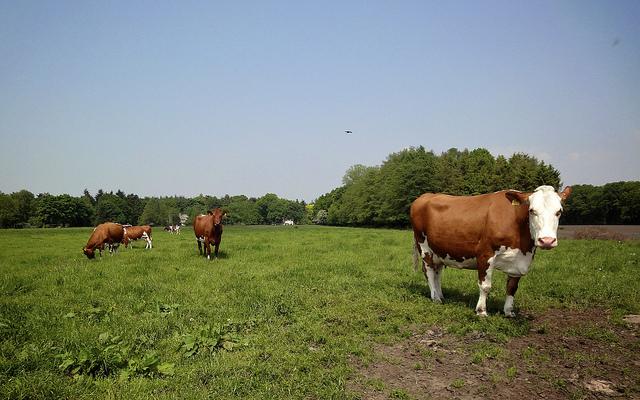Is he fenced in?
Answer briefly. No. Is the sky cloudy or clear?
Be succinct. Clear. Are the cows grazing?
Quick response, please. Yes. What do these animals provide for people to drink?
Keep it brief. Milk. Are there clouds in the sky?
Concise answer only. No. Are there any trees near this cow?
Concise answer only. Yes. How many cows are present?
Answer briefly. 5. What sound do these animals make?
Be succinct. Moo. Is this cow standing near a stone tower??
Keep it brief. No. Which cow has the head down?
Short answer required. Far left. 